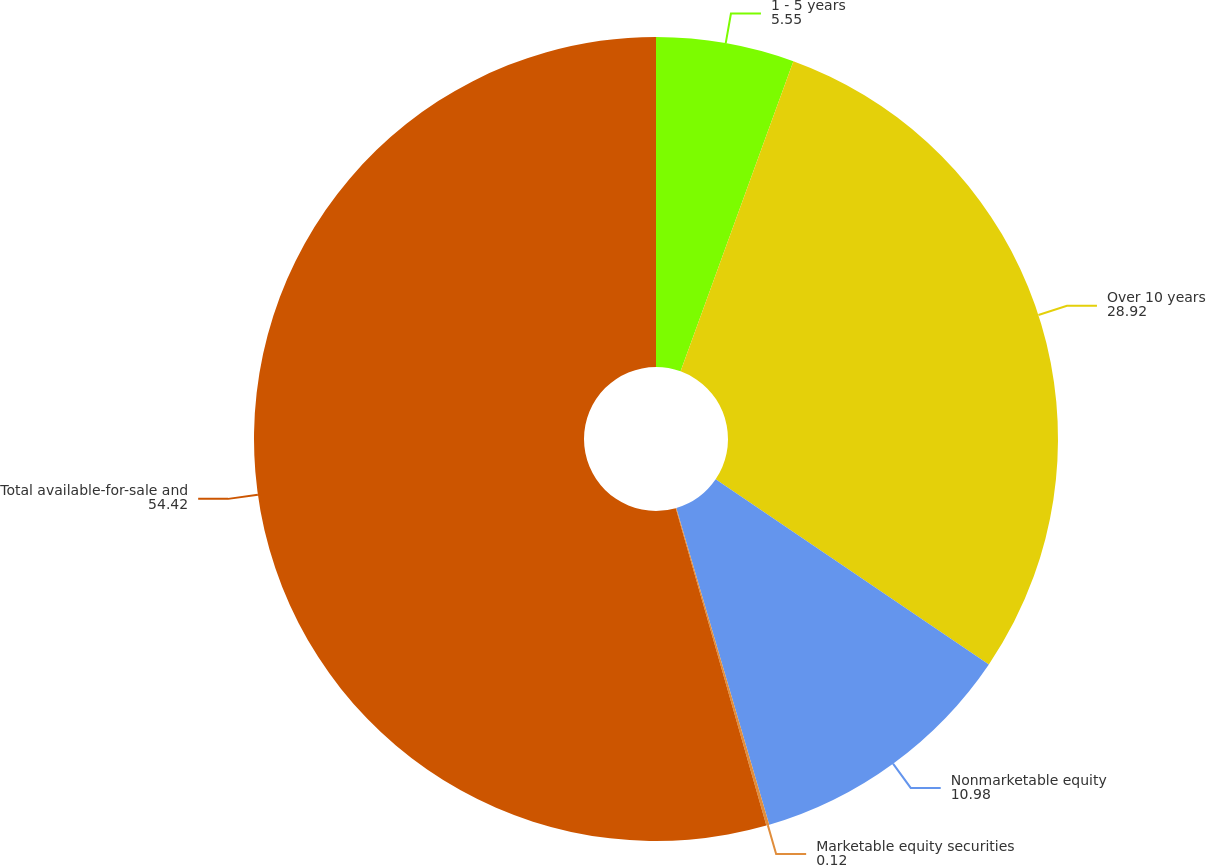Convert chart. <chart><loc_0><loc_0><loc_500><loc_500><pie_chart><fcel>1 - 5 years<fcel>Over 10 years<fcel>Nonmarketable equity<fcel>Marketable equity securities<fcel>Total available-for-sale and<nl><fcel>5.55%<fcel>28.92%<fcel>10.98%<fcel>0.12%<fcel>54.42%<nl></chart> 